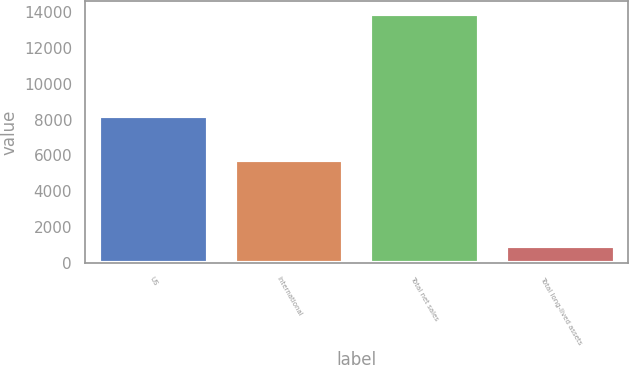<chart> <loc_0><loc_0><loc_500><loc_500><bar_chart><fcel>US<fcel>International<fcel>Total net sales<fcel>Total long-lived assets<nl><fcel>8194<fcel>5737<fcel>13931<fcel>913<nl></chart> 